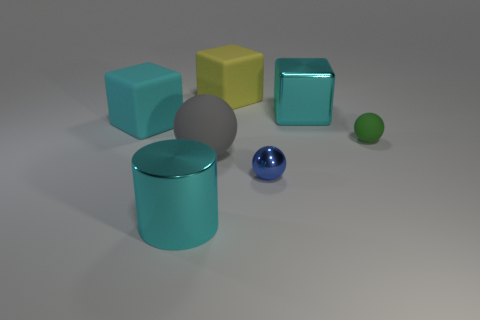Subtract all small rubber balls. How many balls are left? 2 Add 3 shiny blocks. How many objects exist? 10 Subtract all yellow cubes. How many cubes are left? 2 Subtract all cubes. How many objects are left? 4 Subtract all yellow spheres. Subtract all yellow blocks. How many spheres are left? 3 Subtract all blue balls. How many purple blocks are left? 0 Subtract all big green balls. Subtract all green spheres. How many objects are left? 6 Add 3 large rubber cubes. How many large rubber cubes are left? 5 Add 2 small rubber spheres. How many small rubber spheres exist? 3 Subtract 2 cyan blocks. How many objects are left? 5 